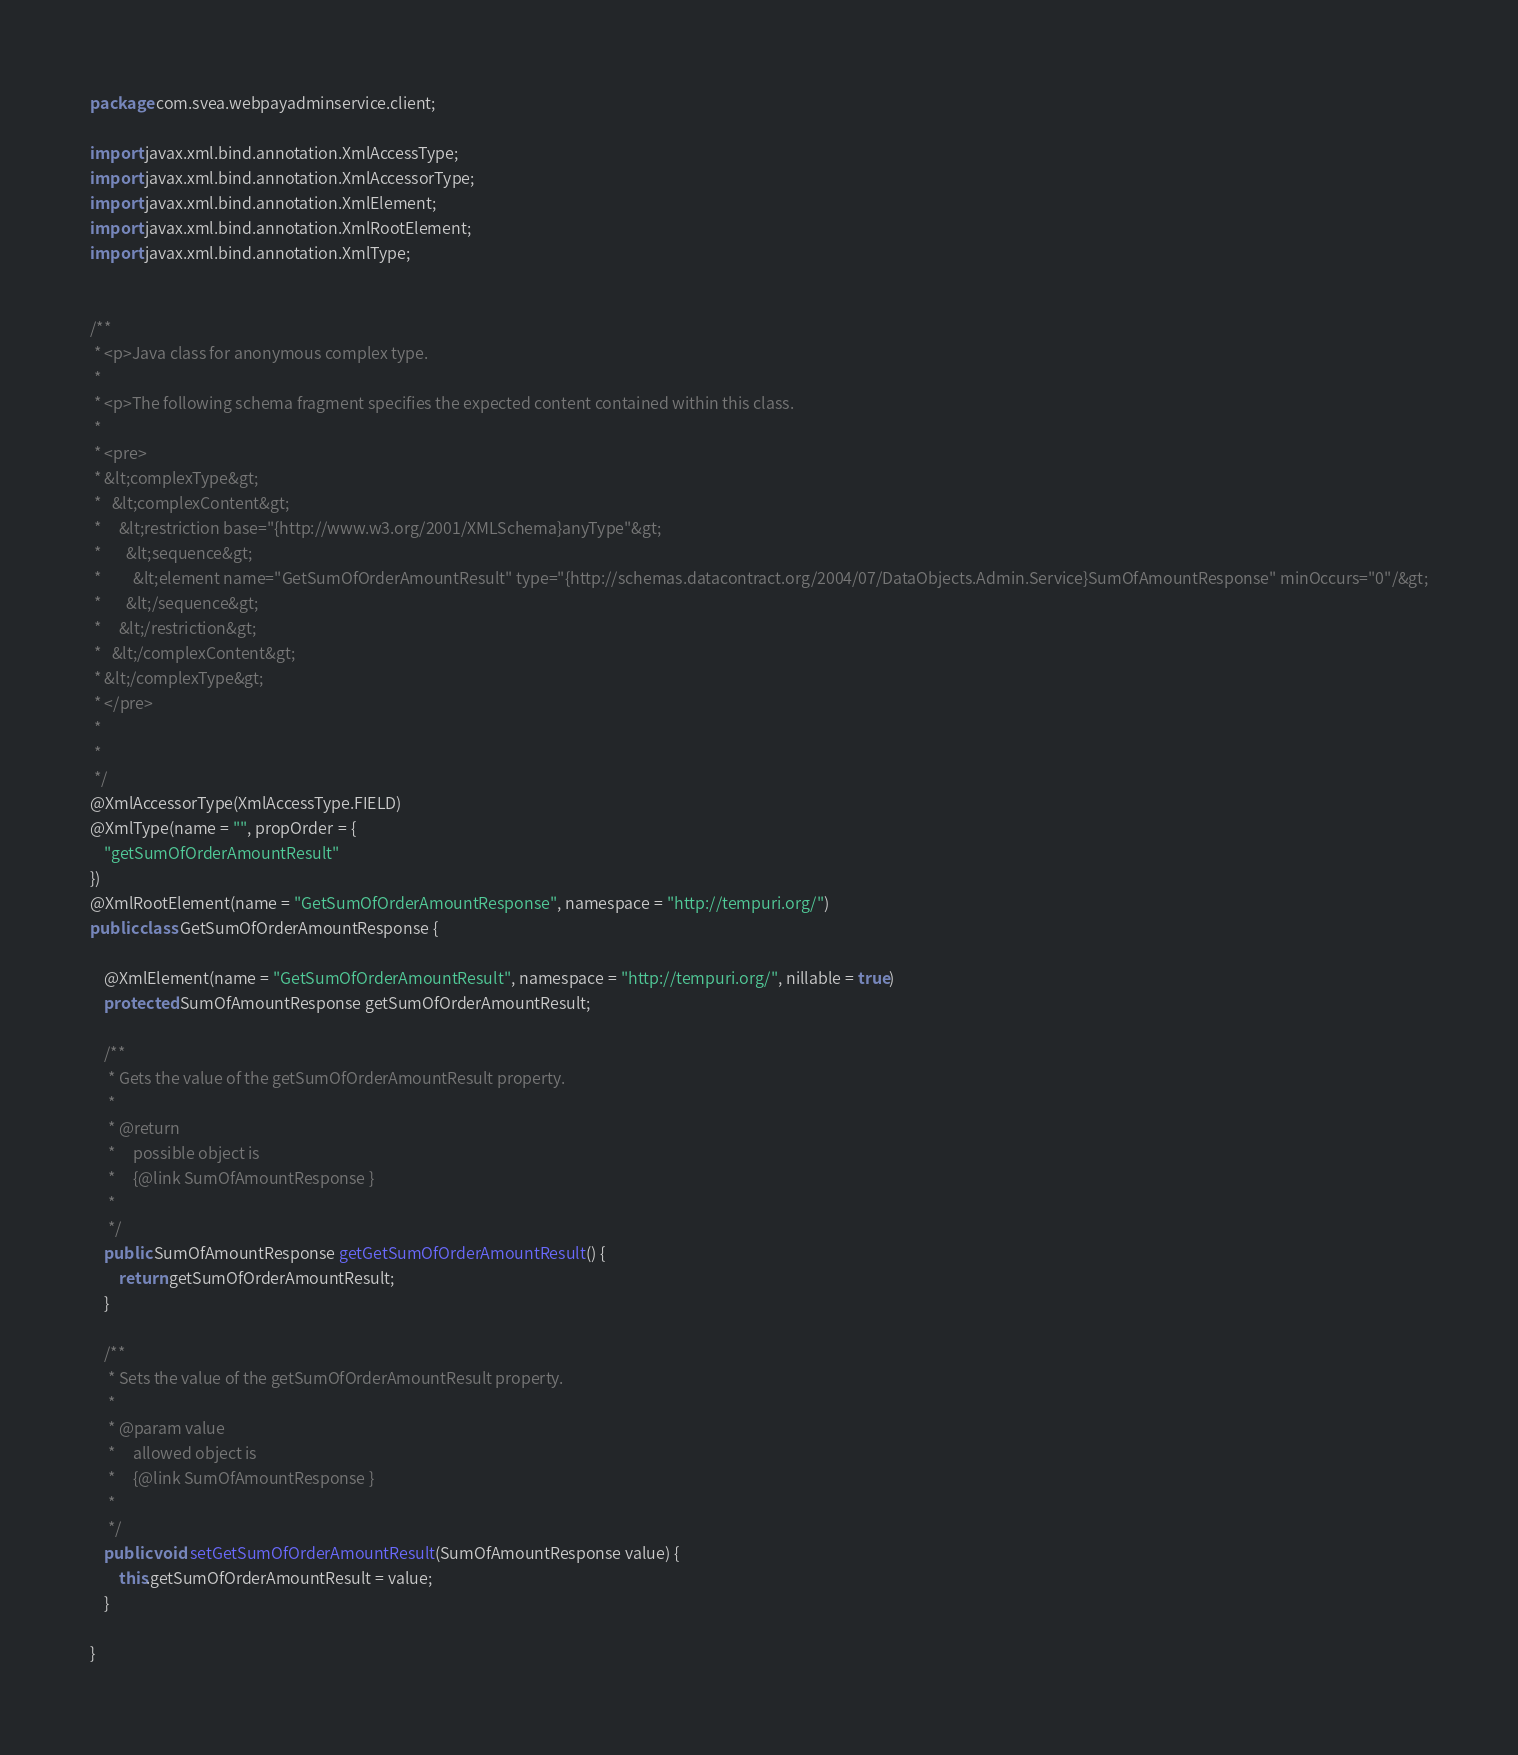Convert code to text. <code><loc_0><loc_0><loc_500><loc_500><_Java_>
package com.svea.webpayadminservice.client;

import javax.xml.bind.annotation.XmlAccessType;
import javax.xml.bind.annotation.XmlAccessorType;
import javax.xml.bind.annotation.XmlElement;
import javax.xml.bind.annotation.XmlRootElement;
import javax.xml.bind.annotation.XmlType;


/**
 * <p>Java class for anonymous complex type.
 * 
 * <p>The following schema fragment specifies the expected content contained within this class.
 * 
 * <pre>
 * &lt;complexType&gt;
 *   &lt;complexContent&gt;
 *     &lt;restriction base="{http://www.w3.org/2001/XMLSchema}anyType"&gt;
 *       &lt;sequence&gt;
 *         &lt;element name="GetSumOfOrderAmountResult" type="{http://schemas.datacontract.org/2004/07/DataObjects.Admin.Service}SumOfAmountResponse" minOccurs="0"/&gt;
 *       &lt;/sequence&gt;
 *     &lt;/restriction&gt;
 *   &lt;/complexContent&gt;
 * &lt;/complexType&gt;
 * </pre>
 * 
 * 
 */
@XmlAccessorType(XmlAccessType.FIELD)
@XmlType(name = "", propOrder = {
    "getSumOfOrderAmountResult"
})
@XmlRootElement(name = "GetSumOfOrderAmountResponse", namespace = "http://tempuri.org/")
public class GetSumOfOrderAmountResponse {

    @XmlElement(name = "GetSumOfOrderAmountResult", namespace = "http://tempuri.org/", nillable = true)
    protected SumOfAmountResponse getSumOfOrderAmountResult;

    /**
     * Gets the value of the getSumOfOrderAmountResult property.
     * 
     * @return
     *     possible object is
     *     {@link SumOfAmountResponse }
     *     
     */
    public SumOfAmountResponse getGetSumOfOrderAmountResult() {
        return getSumOfOrderAmountResult;
    }

    /**
     * Sets the value of the getSumOfOrderAmountResult property.
     * 
     * @param value
     *     allowed object is
     *     {@link SumOfAmountResponse }
     *     
     */
    public void setGetSumOfOrderAmountResult(SumOfAmountResponse value) {
        this.getSumOfOrderAmountResult = value;
    }

}
</code> 